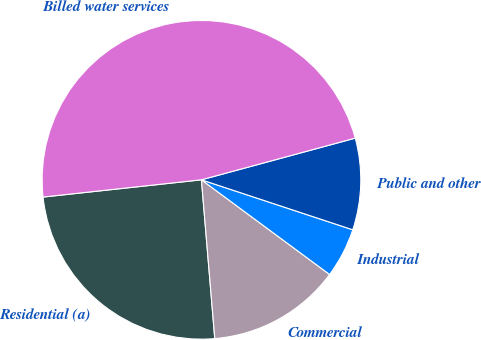Convert chart to OTSL. <chart><loc_0><loc_0><loc_500><loc_500><pie_chart><fcel>Residential (a)<fcel>Commercial<fcel>Industrial<fcel>Public and other<fcel>Billed water services<nl><fcel>24.61%<fcel>13.54%<fcel>5.05%<fcel>9.29%<fcel>47.52%<nl></chart> 